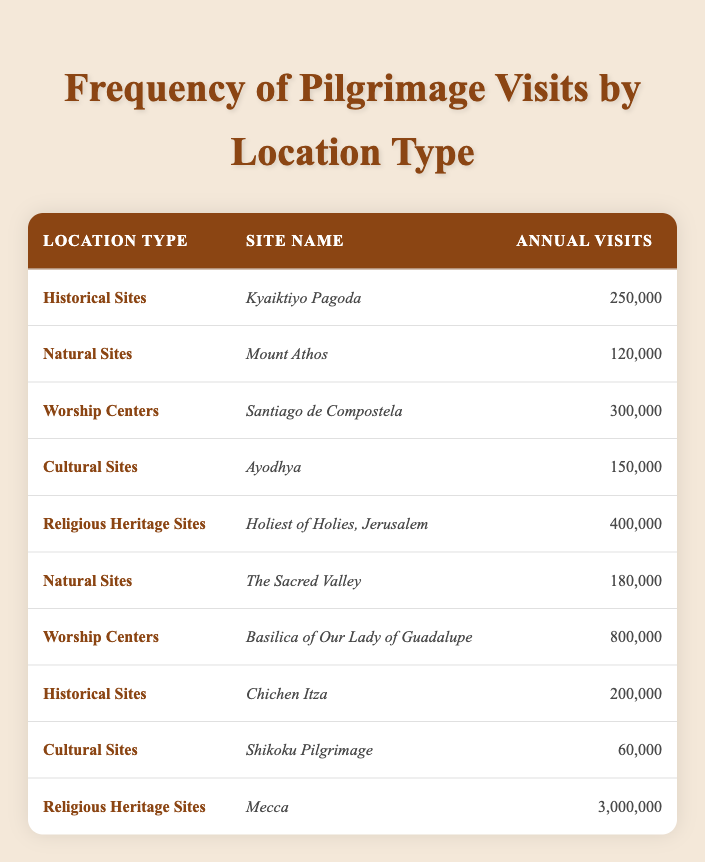What is the site with the highest number of annual visits? The site with the highest number of annual visits in the table is Mecca, which has 3,000,000 annual visits. This can be directly identified by looking at the "Annual Visits" column in the table.
Answer: Mecca Which location type has the most sites listed in the table? The table presents three different location types with multiple sites. "Natural Sites" includes two entries (Mount Athos and The Sacred Valley), "Worship Centers" also includes two (Santiago de Compostela and Basilica of Our Lady of Guadalupe), and "Historical Sites" includes two (Kyaiktiyo Pagoda and Chichen Itza). However, "Religious Heritage Sites" has only two entries. Therefore, all listed location types have the same count but they appear equal.
Answer: Equal number What is the total number of visits for all Worship Centers? The number of visits for Worship Centers can be summed up: Santiago de Compostela (300,000) + Basilica of Our Lady of Guadalupe (800,000) = 1,100,000. Thus, the total for Worship Centers is 1,100,000.
Answer: 1,100,000 Is the site "Ayodhya" a Worship Center? By examining the "Location Type" for Ayodhya in the table, it is classified under "Cultural Sites" and not as a Worship Center. Therefore, the statement is false.
Answer: No What is the average number of annual visits for Historical Sites? There are two Historical Sites listed: Kyaiktiyo Pagoda (250,000) and Chichen Itza (200,000). To find the average, sum these visits: 250,000 + 200,000 = 450,000. Then divide by the number of sites (2), so 450,000 / 2 = 225,000.
Answer: 225,000 Which site type has the least number of visits? From the table, cultural sites, such as Shikoku Pilgrimage (60,000), have the least number of visits. Comparing all other sites, Shikoku is the one with the lowest figure.
Answer: Shikoku Pilgrimage How many visits does the site "Basilica of Our Lady of Guadalupe" have compared to the total number of visits at "Natural Sites"? The Basilica of Our Lady of Guadalupe has 800,000 visits, while Natural Sites have totals of Mount Athos (120,000) and The Sacred Valley (180,000), summing to 300,000. Thus, 800,000 (Basilica) is greater than 300,000 (Natural Sites).
Answer: Greater What is the difference in annual visits between the highest and lowest site in "Religious Heritage Sites"? The Religious Heritage Sites include Holiest of Holies, Jerusalem (400,000) and Mecca (3,000,000). The difference is 3,000,000 - 400,000 = 2,600,000.
Answer: 2,600,000 